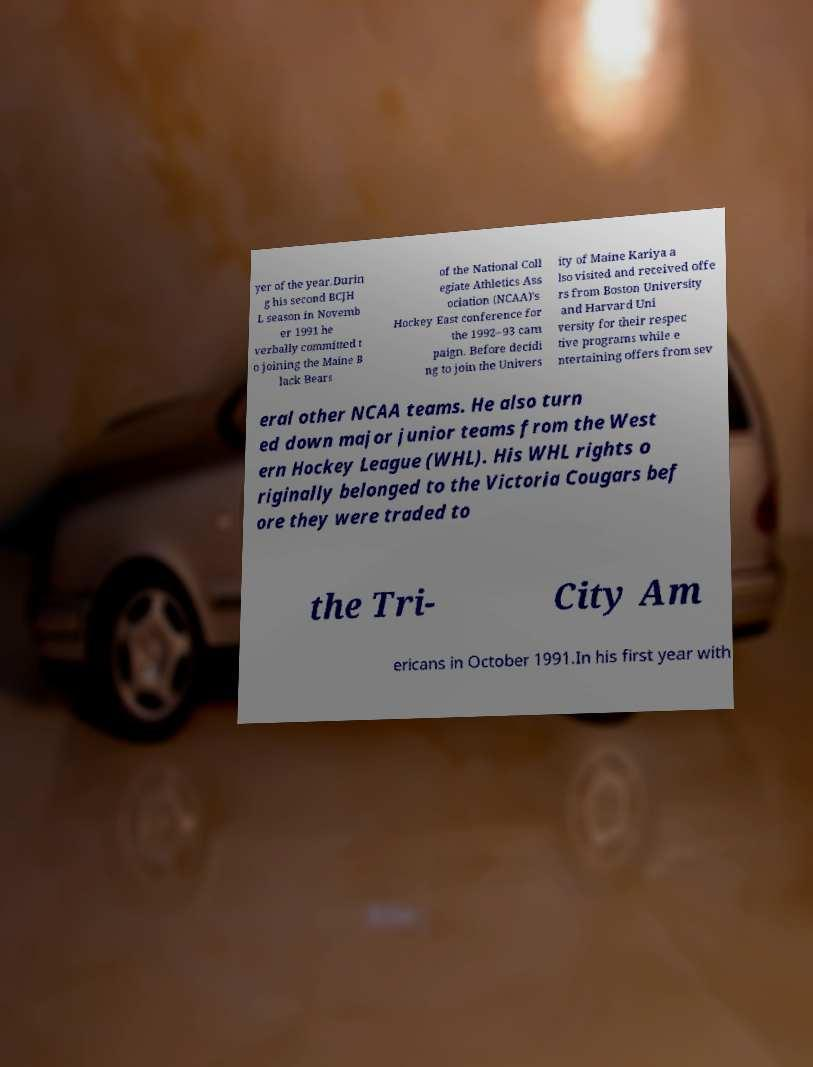What messages or text are displayed in this image? I need them in a readable, typed format. yer of the year.Durin g his second BCJH L season in Novemb er 1991 he verbally committed t o joining the Maine B lack Bears of the National Coll egiate Athletics Ass ociation (NCAA)'s Hockey East conference for the 1992–93 cam paign. Before decidi ng to join the Univers ity of Maine Kariya a lso visited and received offe rs from Boston University and Harvard Uni versity for their respec tive programs while e ntertaining offers from sev eral other NCAA teams. He also turn ed down major junior teams from the West ern Hockey League (WHL). His WHL rights o riginally belonged to the Victoria Cougars bef ore they were traded to the Tri- City Am ericans in October 1991.In his first year with 